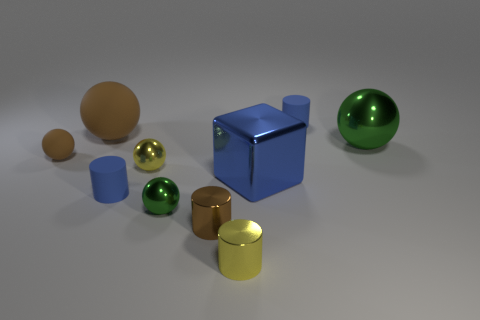Do the cube and the rubber cylinder that is right of the small yellow ball have the same size?
Provide a succinct answer. No. There is a green shiny object that is on the right side of the tiny green object on the left side of the tiny yellow shiny thing that is right of the yellow metal ball; what shape is it?
Your response must be concise. Sphere. There is a shiny sphere that is both on the left side of the large green metallic sphere and behind the big block; what is its color?
Give a very brief answer. Yellow. The metal object right of the block has what shape?
Your answer should be very brief. Sphere. What shape is the small brown thing that is made of the same material as the large brown sphere?
Your answer should be compact. Sphere. What number of matte objects are either small yellow cylinders or big blue cylinders?
Provide a succinct answer. 0. There is a small metallic object that is behind the blue matte object that is in front of the tiny brown rubber ball; what number of big brown matte spheres are left of it?
Keep it short and to the point. 1. There is a blue metallic cube to the left of the big shiny ball; does it have the same size as the blue cylinder behind the big green metallic ball?
Your response must be concise. No. There is a small brown object that is the same shape as the big green thing; what material is it?
Your response must be concise. Rubber. What number of tiny things are red blocks or metallic cylinders?
Keep it short and to the point. 2. 